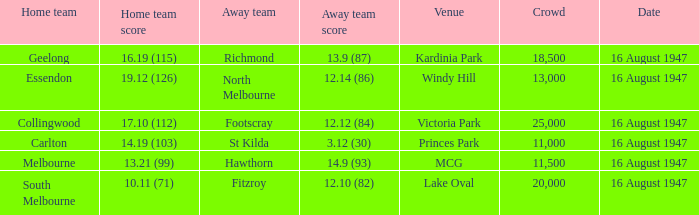What was the overall capacity of the audience when the visiting team scored 1 20000.0. 